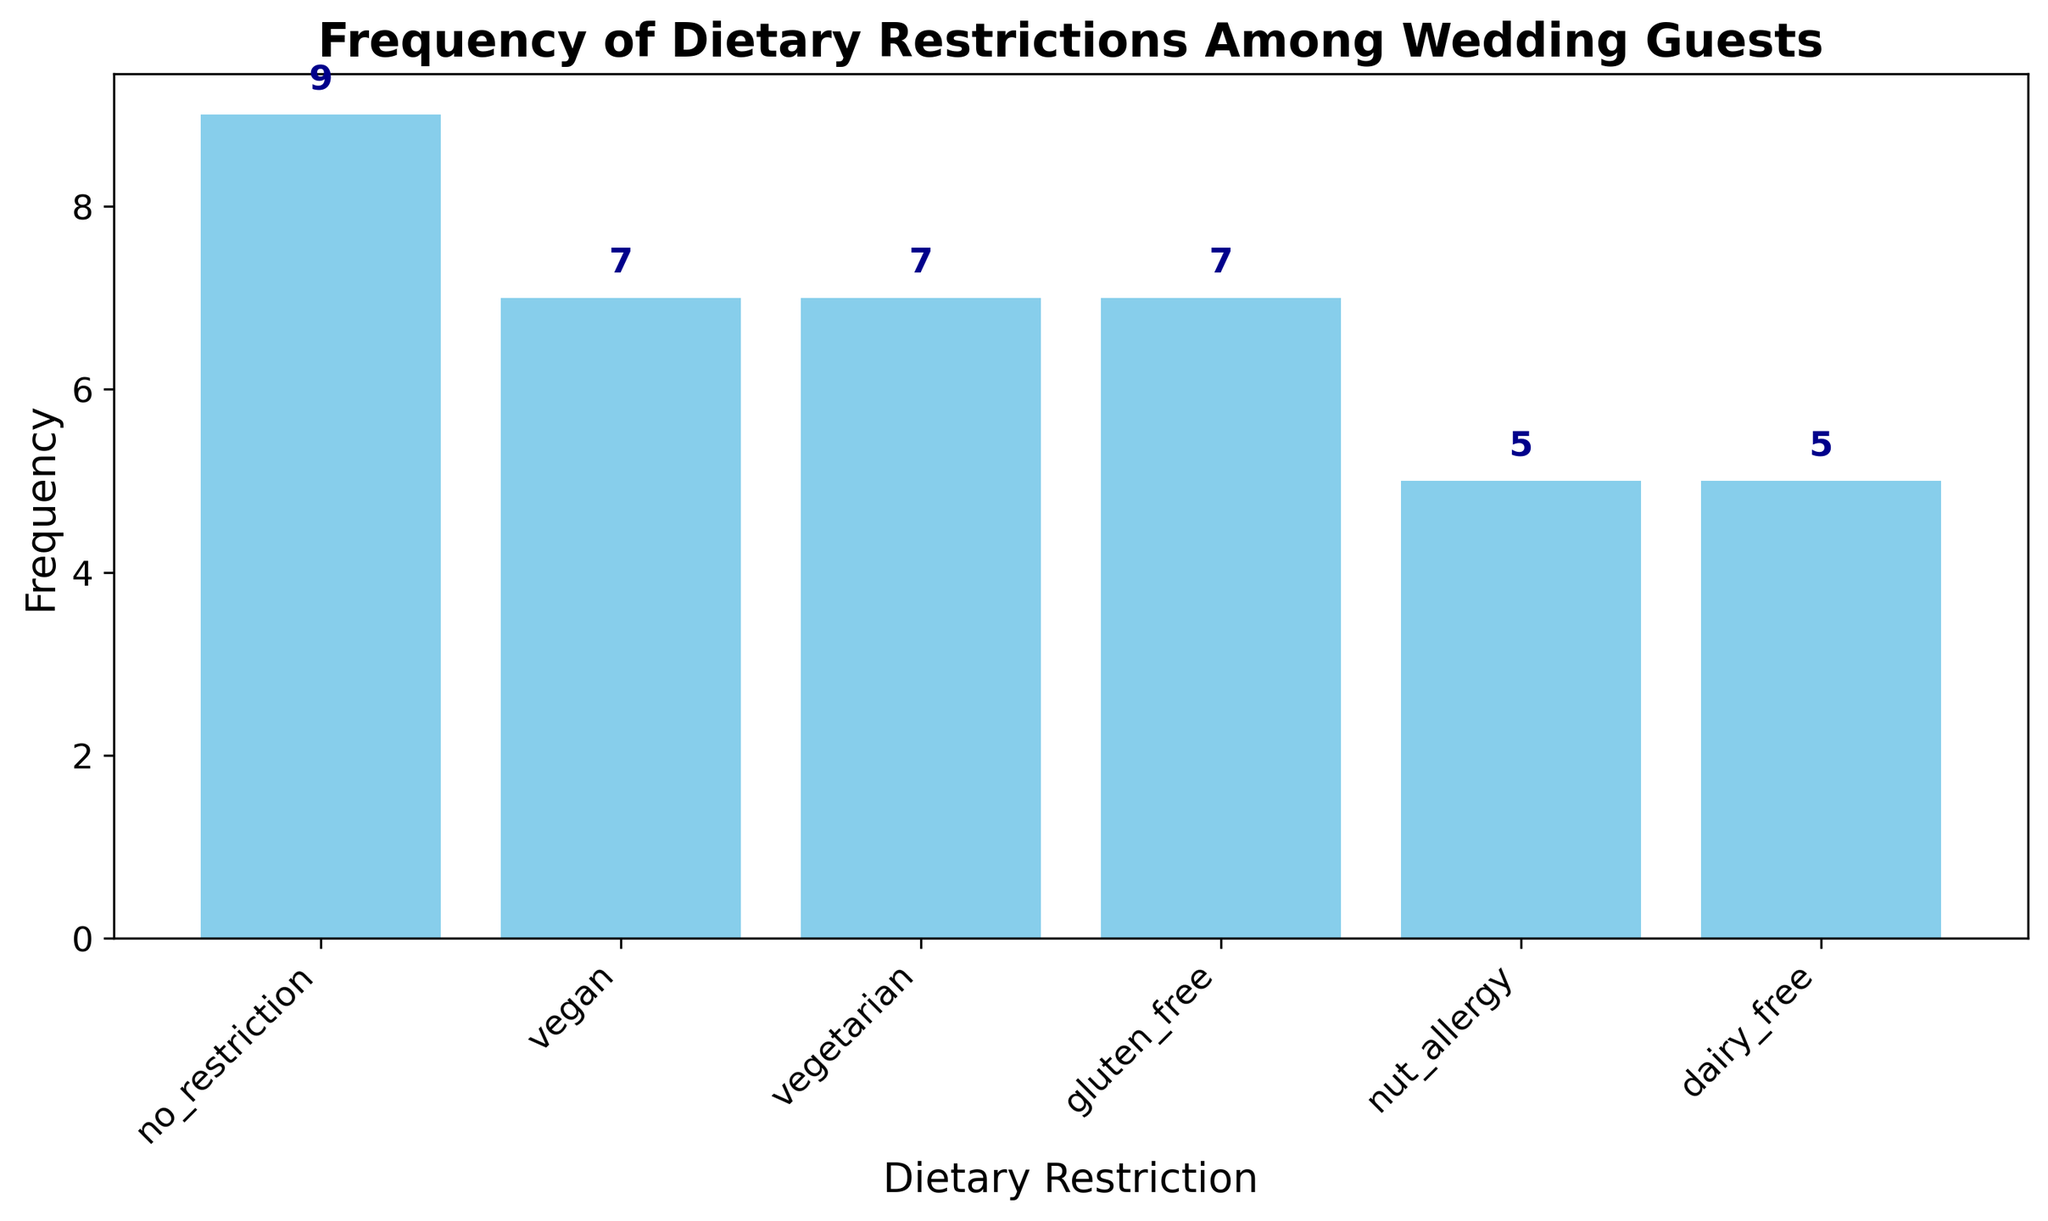Which dietary restriction has the highest frequency among wedding guests? The height of the bars represents the frequency of each dietary restriction. The tallest bar corresponds to "no_restriction."
Answer: no_restriction Which dietary restriction has the lowest frequency among wedding guests? By looking at the bar heights, the shortest bars represent the dietary restrictions with the lowest frequencies, "dairy_free" is one of them.
Answer: dairy_free How many total guests have dietary restrictions (excluding 'no_restriction')? Sum the heights of all bars except "no_restriction." Vegan (6) + Vegetarian (6) + Gluten_free (5) + Nut_allergy (4) + Dairy_free (4) = 25
Answer: 25 How does the frequency of 'vegetarian' guests compare to 'nut_allergy' guests? Compare the heights of the bars for 'vegetarian' (6) and 'nut_allergy' (4). The bar for 'vegetarian' is taller than 'nut_allergy.'
Answer: Vegetarian is more frequent What is the combined frequency of 'vegan' and 'gluten_free' dietary restrictions? Add the frequencies of 'vegan' (6) and 'gluten_free' (5). 6 + 5 = 11
Answer: 11 Are there more 'vegan' or 'dairy_free' guests? Compare the heights of the bars for 'vegan' (6) and 'dairy_free' (4). The 'vegan' bar is taller.
Answer: More vegan guests What is the difference in frequency between 'no_restriction' and 'vegetarian'? Subtract the frequency of 'vegetarian' (6) from 'no_restriction' (10). 10 - 6 = 4
Answer: 4 Which dietary restriction has, at least, twice the frequency of 'nut_allergy'? 'Nut_allergy' has a frequency of 4. Identify bars with frequencies of at least 8 or more, which is 'no_restriction' (10).
Answer: no_restriction What is the second most common dietary restriction? The second tallest bar represents the second most common dietary restriction, which is 'vegan' and 'vegetarian' (both 6).
Answer: vegan and vegetarian 